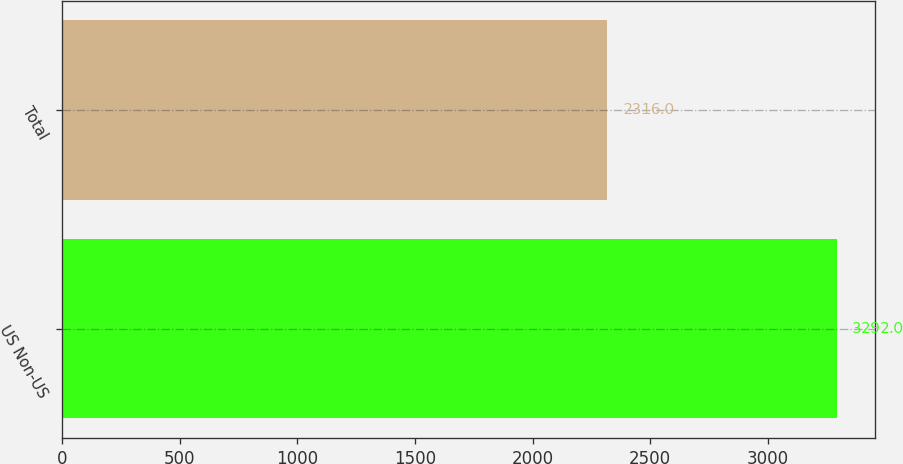Convert chart. <chart><loc_0><loc_0><loc_500><loc_500><bar_chart><fcel>US Non-US<fcel>Total<nl><fcel>3292<fcel>2316<nl></chart> 